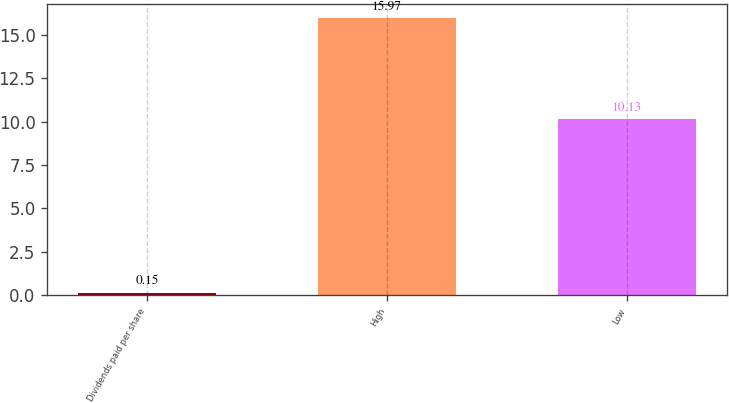Convert chart. <chart><loc_0><loc_0><loc_500><loc_500><bar_chart><fcel>Dividends paid per share<fcel>High<fcel>Low<nl><fcel>0.15<fcel>15.97<fcel>10.13<nl></chart> 